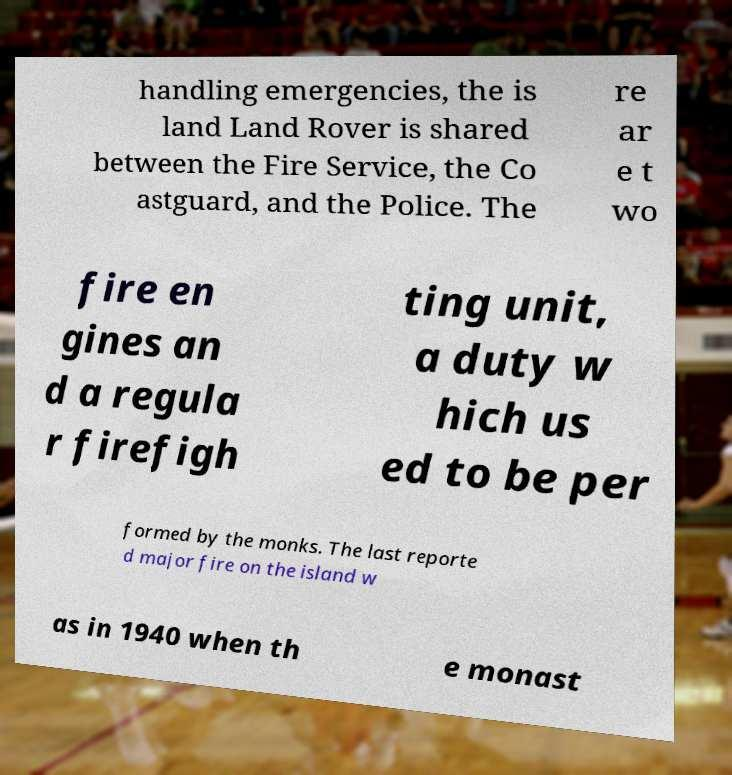Please identify and transcribe the text found in this image. handling emergencies, the is land Land Rover is shared between the Fire Service, the Co astguard, and the Police. The re ar e t wo fire en gines an d a regula r firefigh ting unit, a duty w hich us ed to be per formed by the monks. The last reporte d major fire on the island w as in 1940 when th e monast 